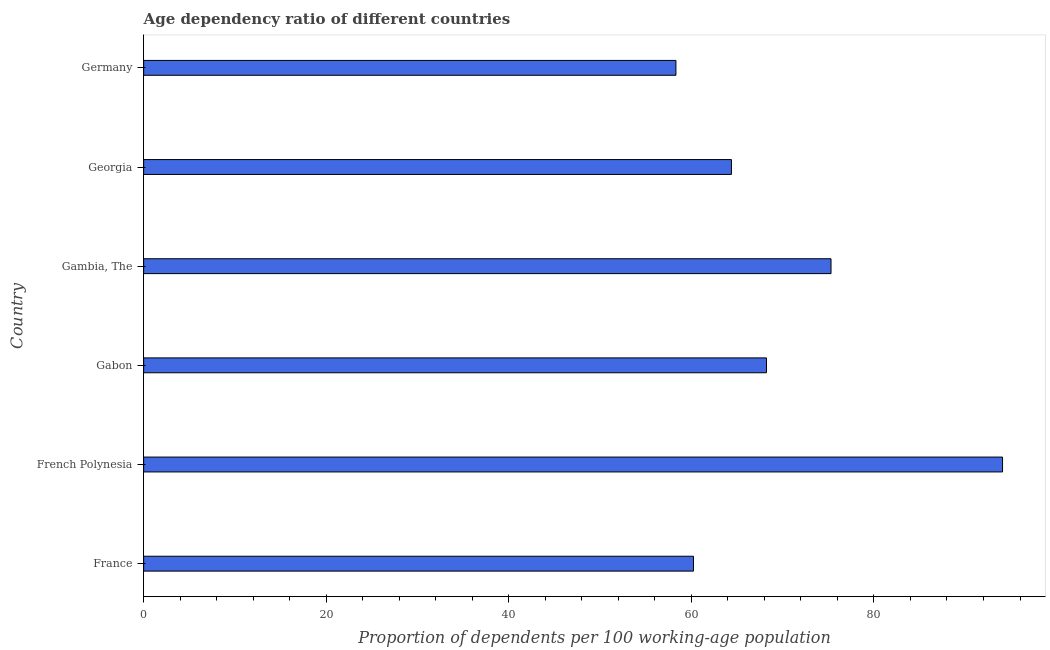Does the graph contain grids?
Make the answer very short. No. What is the title of the graph?
Provide a short and direct response. Age dependency ratio of different countries. What is the label or title of the X-axis?
Ensure brevity in your answer.  Proportion of dependents per 100 working-age population. What is the age dependency ratio in Germany?
Provide a short and direct response. 58.31. Across all countries, what is the maximum age dependency ratio?
Give a very brief answer. 94.09. Across all countries, what is the minimum age dependency ratio?
Keep it short and to the point. 58.31. In which country was the age dependency ratio maximum?
Keep it short and to the point. French Polynesia. In which country was the age dependency ratio minimum?
Provide a succinct answer. Germany. What is the sum of the age dependency ratio?
Your answer should be compact. 420.53. What is the difference between the age dependency ratio in France and Georgia?
Give a very brief answer. -4.16. What is the average age dependency ratio per country?
Give a very brief answer. 70.09. What is the median age dependency ratio?
Make the answer very short. 66.31. What is the ratio of the age dependency ratio in Gabon to that in Georgia?
Give a very brief answer. 1.06. What is the difference between the highest and the second highest age dependency ratio?
Your answer should be compact. 18.79. Is the sum of the age dependency ratio in French Polynesia and Germany greater than the maximum age dependency ratio across all countries?
Your response must be concise. Yes. What is the difference between the highest and the lowest age dependency ratio?
Ensure brevity in your answer.  35.78. In how many countries, is the age dependency ratio greater than the average age dependency ratio taken over all countries?
Your answer should be very brief. 2. Are all the bars in the graph horizontal?
Ensure brevity in your answer.  Yes. What is the difference between two consecutive major ticks on the X-axis?
Keep it short and to the point. 20. Are the values on the major ticks of X-axis written in scientific E-notation?
Ensure brevity in your answer.  No. What is the Proportion of dependents per 100 working-age population in France?
Make the answer very short. 60.23. What is the Proportion of dependents per 100 working-age population of French Polynesia?
Make the answer very short. 94.09. What is the Proportion of dependents per 100 working-age population of Gabon?
Your answer should be very brief. 68.23. What is the Proportion of dependents per 100 working-age population of Gambia, The?
Ensure brevity in your answer.  75.3. What is the Proportion of dependents per 100 working-age population of Georgia?
Make the answer very short. 64.39. What is the Proportion of dependents per 100 working-age population in Germany?
Your response must be concise. 58.31. What is the difference between the Proportion of dependents per 100 working-age population in France and French Polynesia?
Your response must be concise. -33.86. What is the difference between the Proportion of dependents per 100 working-age population in France and Gabon?
Keep it short and to the point. -8. What is the difference between the Proportion of dependents per 100 working-age population in France and Gambia, The?
Give a very brief answer. -15.07. What is the difference between the Proportion of dependents per 100 working-age population in France and Georgia?
Offer a very short reply. -4.16. What is the difference between the Proportion of dependents per 100 working-age population in France and Germany?
Provide a short and direct response. 1.92. What is the difference between the Proportion of dependents per 100 working-age population in French Polynesia and Gabon?
Keep it short and to the point. 25.86. What is the difference between the Proportion of dependents per 100 working-age population in French Polynesia and Gambia, The?
Offer a very short reply. 18.79. What is the difference between the Proportion of dependents per 100 working-age population in French Polynesia and Georgia?
Provide a succinct answer. 29.7. What is the difference between the Proportion of dependents per 100 working-age population in French Polynesia and Germany?
Your response must be concise. 35.78. What is the difference between the Proportion of dependents per 100 working-age population in Gabon and Gambia, The?
Make the answer very short. -7.07. What is the difference between the Proportion of dependents per 100 working-age population in Gabon and Georgia?
Offer a terse response. 3.84. What is the difference between the Proportion of dependents per 100 working-age population in Gabon and Germany?
Your answer should be very brief. 9.92. What is the difference between the Proportion of dependents per 100 working-age population in Gambia, The and Georgia?
Make the answer very short. 10.91. What is the difference between the Proportion of dependents per 100 working-age population in Gambia, The and Germany?
Give a very brief answer. 16.99. What is the difference between the Proportion of dependents per 100 working-age population in Georgia and Germany?
Your answer should be compact. 6.08. What is the ratio of the Proportion of dependents per 100 working-age population in France to that in French Polynesia?
Your answer should be very brief. 0.64. What is the ratio of the Proportion of dependents per 100 working-age population in France to that in Gabon?
Keep it short and to the point. 0.88. What is the ratio of the Proportion of dependents per 100 working-age population in France to that in Georgia?
Offer a terse response. 0.94. What is the ratio of the Proportion of dependents per 100 working-age population in France to that in Germany?
Provide a succinct answer. 1.03. What is the ratio of the Proportion of dependents per 100 working-age population in French Polynesia to that in Gabon?
Keep it short and to the point. 1.38. What is the ratio of the Proportion of dependents per 100 working-age population in French Polynesia to that in Gambia, The?
Ensure brevity in your answer.  1.25. What is the ratio of the Proportion of dependents per 100 working-age population in French Polynesia to that in Georgia?
Your response must be concise. 1.46. What is the ratio of the Proportion of dependents per 100 working-age population in French Polynesia to that in Germany?
Provide a succinct answer. 1.61. What is the ratio of the Proportion of dependents per 100 working-age population in Gabon to that in Gambia, The?
Offer a very short reply. 0.91. What is the ratio of the Proportion of dependents per 100 working-age population in Gabon to that in Georgia?
Give a very brief answer. 1.06. What is the ratio of the Proportion of dependents per 100 working-age population in Gabon to that in Germany?
Keep it short and to the point. 1.17. What is the ratio of the Proportion of dependents per 100 working-age population in Gambia, The to that in Georgia?
Give a very brief answer. 1.17. What is the ratio of the Proportion of dependents per 100 working-age population in Gambia, The to that in Germany?
Offer a very short reply. 1.29. What is the ratio of the Proportion of dependents per 100 working-age population in Georgia to that in Germany?
Give a very brief answer. 1.1. 